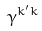Convert formula to latex. <formula><loc_0><loc_0><loc_500><loc_500>\gamma ^ { k ^ { \prime } k }</formula> 